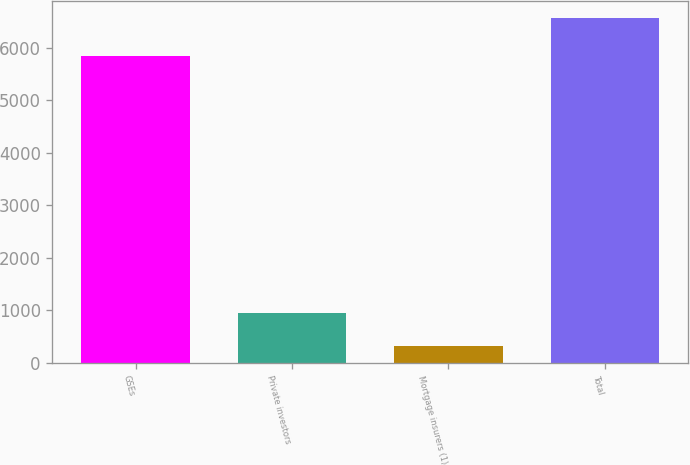<chart> <loc_0><loc_0><loc_500><loc_500><bar_chart><fcel>GSEs<fcel>Private investors<fcel>Mortgage insurers (1)<fcel>Total<nl><fcel>5835<fcel>940.4<fcel>316<fcel>6560<nl></chart> 